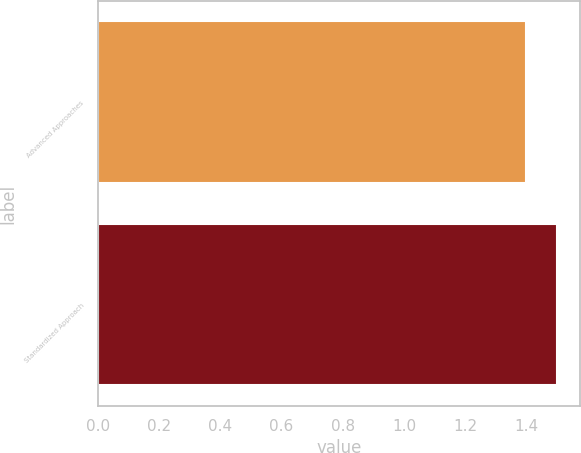<chart> <loc_0><loc_0><loc_500><loc_500><bar_chart><fcel>Advanced Approaches<fcel>Standardized Approach<nl><fcel>1.4<fcel>1.5<nl></chart> 